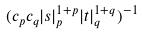Convert formula to latex. <formula><loc_0><loc_0><loc_500><loc_500>( c _ { p } c _ { q } | s | _ { p } ^ { 1 + p } | t | _ { q } ^ { 1 + q } ) ^ { - 1 }</formula> 